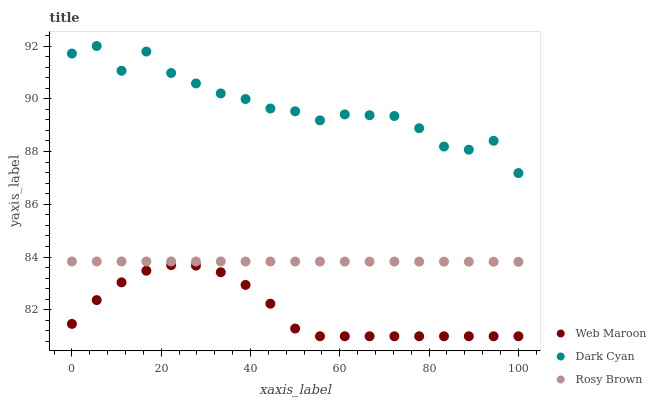Does Web Maroon have the minimum area under the curve?
Answer yes or no. Yes. Does Dark Cyan have the maximum area under the curve?
Answer yes or no. Yes. Does Rosy Brown have the minimum area under the curve?
Answer yes or no. No. Does Rosy Brown have the maximum area under the curve?
Answer yes or no. No. Is Rosy Brown the smoothest?
Answer yes or no. Yes. Is Dark Cyan the roughest?
Answer yes or no. Yes. Is Web Maroon the smoothest?
Answer yes or no. No. Is Web Maroon the roughest?
Answer yes or no. No. Does Web Maroon have the lowest value?
Answer yes or no. Yes. Does Rosy Brown have the lowest value?
Answer yes or no. No. Does Dark Cyan have the highest value?
Answer yes or no. Yes. Does Rosy Brown have the highest value?
Answer yes or no. No. Is Web Maroon less than Rosy Brown?
Answer yes or no. Yes. Is Dark Cyan greater than Web Maroon?
Answer yes or no. Yes. Does Web Maroon intersect Rosy Brown?
Answer yes or no. No. 